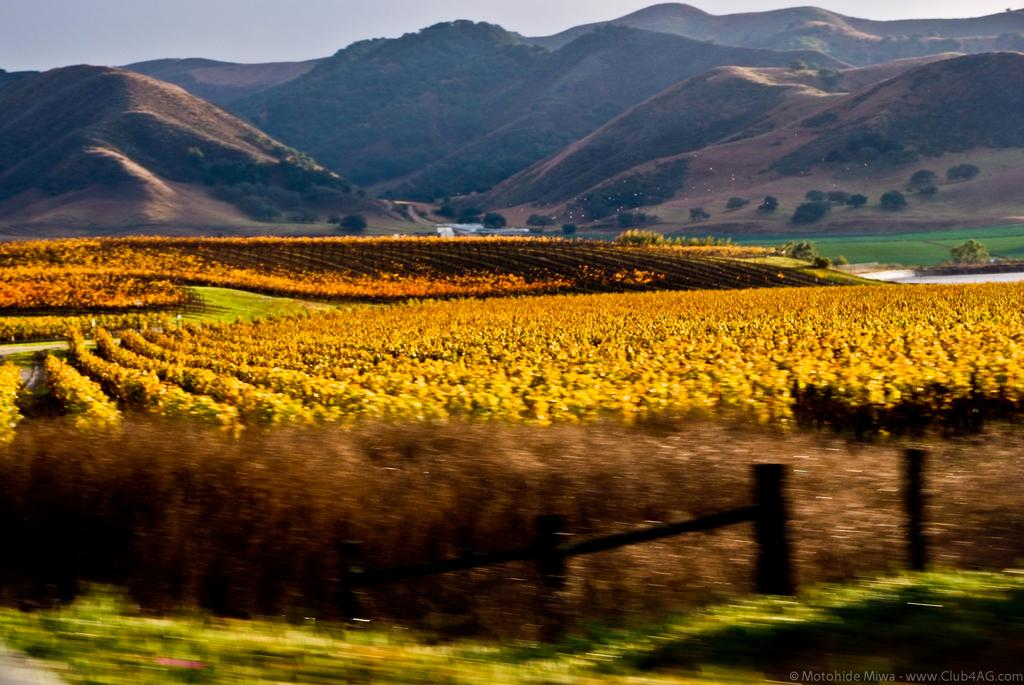What color are the plants in the image? The plants in the image are yellow. What type of natural landform can be seen in the image? There are mountains in the image. What type of vegetation is present in the image besides the yellow plants? There are trees in the image. What type of ground cover is visible in the image? There is grass visible in the image. What type of destruction can be seen in the image? There is no destruction present in the image; it features natural elements such as plants, mountains, trees, and grass. What type of seed is used to grow the yellow plants in the image? There is no information about the type of seed used to grow the yellow plants in the image. 